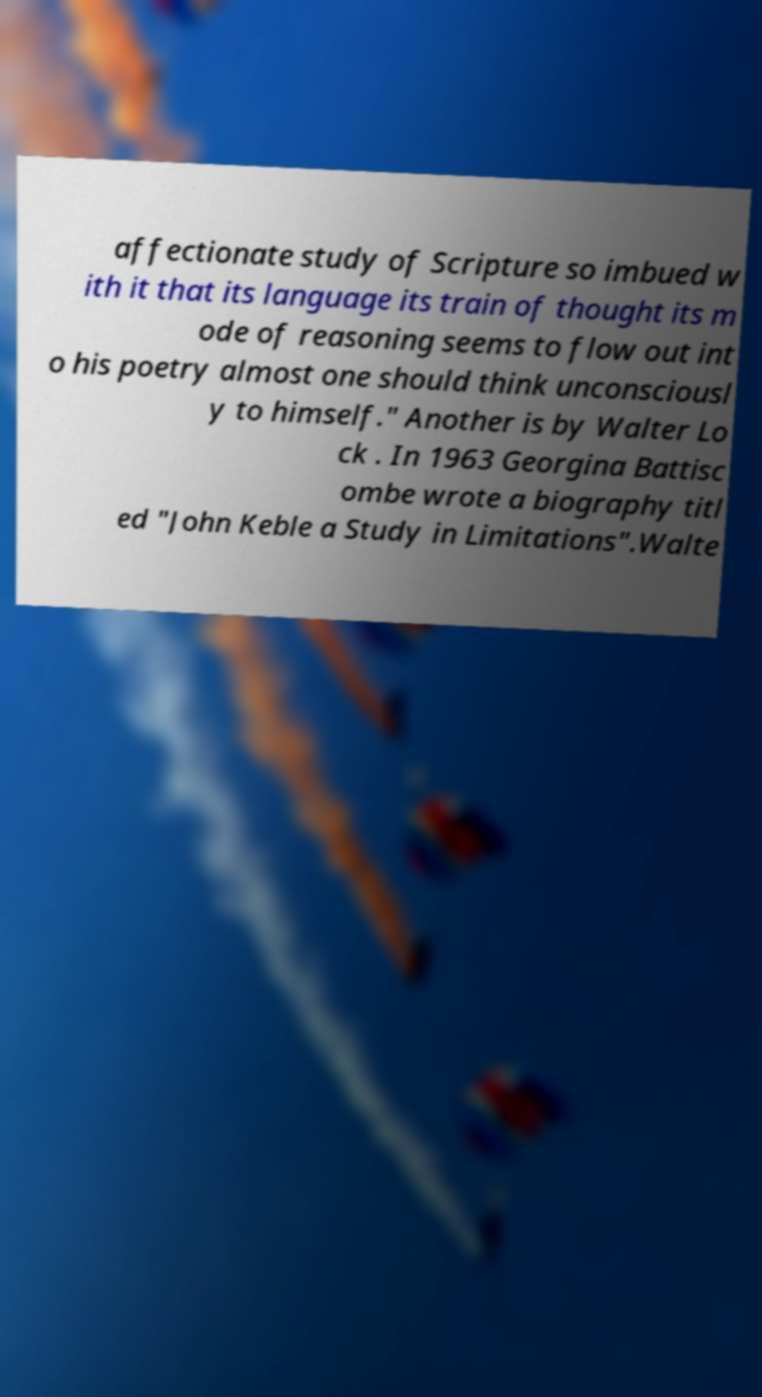For documentation purposes, I need the text within this image transcribed. Could you provide that? affectionate study of Scripture so imbued w ith it that its language its train of thought its m ode of reasoning seems to flow out int o his poetry almost one should think unconsciousl y to himself." Another is by Walter Lo ck . In 1963 Georgina Battisc ombe wrote a biography titl ed "John Keble a Study in Limitations".Walte 